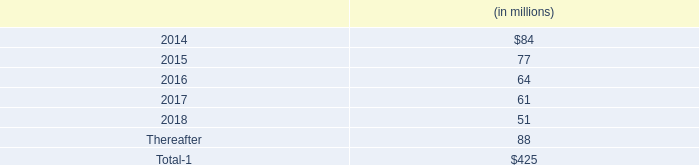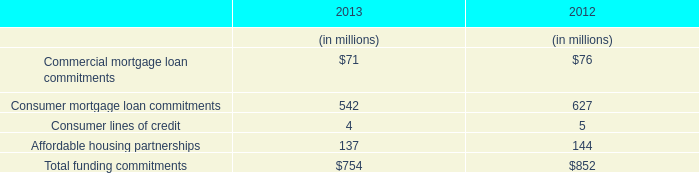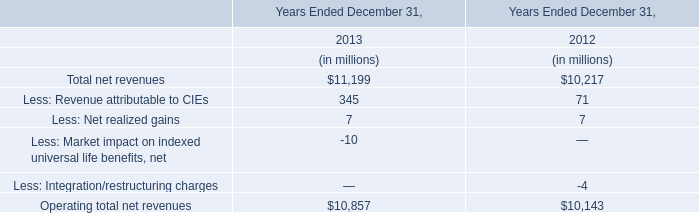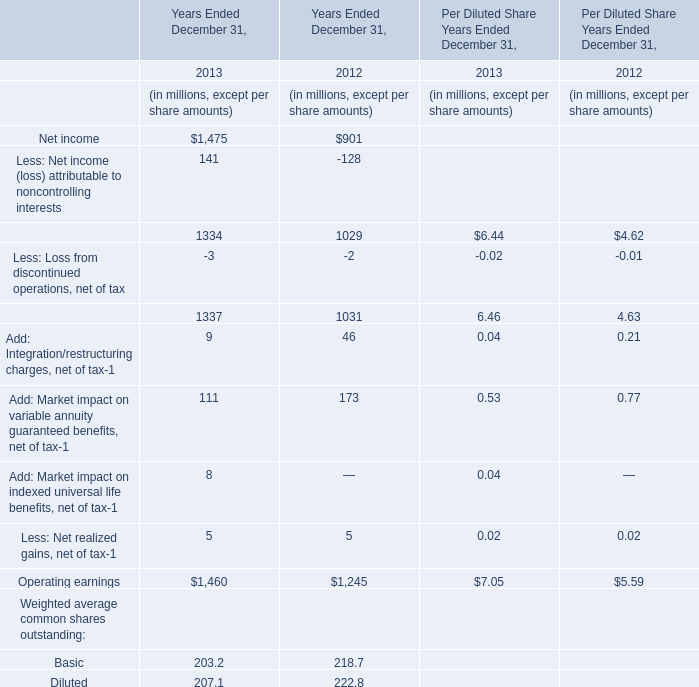In the year with the most Total net revenues in table 2, what is the growth rate of Operating total net revenues in table 2? 
Computations: ((10857 - 10143) / 10143)
Answer: 0.07039. 